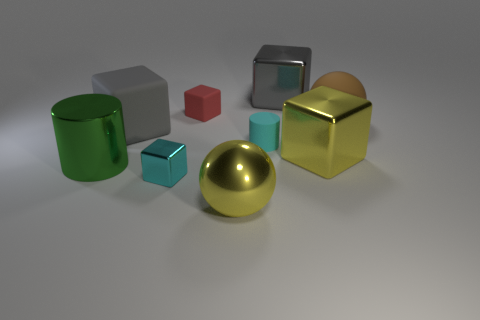What number of small metallic objects are the same color as the small rubber cylinder?
Offer a very short reply. 1. There is a thing that is the same color as the big metallic ball; what material is it?
Offer a very short reply. Metal. There is a small metal block; does it have the same color as the small matte object that is to the right of the shiny sphere?
Ensure brevity in your answer.  Yes. What number of other things are there of the same color as the small rubber cylinder?
Your answer should be compact. 1. Is the size of the yellow metal object that is behind the large green cylinder the same as the matte object that is on the left side of the tiny cyan cube?
Provide a succinct answer. Yes. There is a tiny cyan object that is the same material as the yellow sphere; what shape is it?
Your response must be concise. Cube. What is the color of the ball on the right side of the gray cube that is on the right side of the cyan thing that is in front of the big green metallic cylinder?
Your answer should be compact. Brown. Are there fewer tiny cyan metal blocks that are on the right side of the yellow sphere than large spheres behind the cyan cylinder?
Give a very brief answer. Yes. Does the small red rubber thing have the same shape as the tiny cyan shiny thing?
Ensure brevity in your answer.  Yes. How many gray balls are the same size as the yellow cube?
Offer a terse response. 0. 